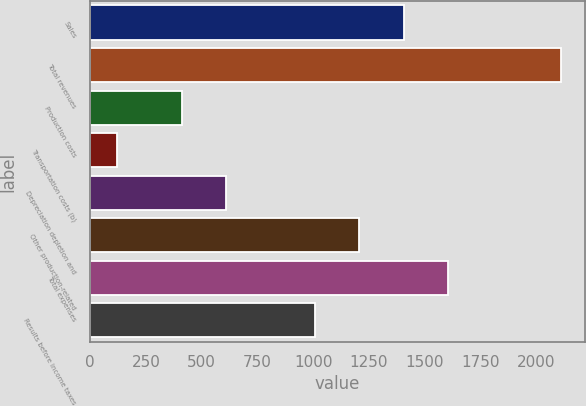<chart> <loc_0><loc_0><loc_500><loc_500><bar_chart><fcel>Sales<fcel>Total revenues<fcel>Production costs<fcel>Transportation costs (b)<fcel>Depreciation depletion and<fcel>Other production-related<fcel>Total expenses<fcel>Results before income taxes<nl><fcel>1406.5<fcel>2113<fcel>410<fcel>120<fcel>609.3<fcel>1207.2<fcel>1605.8<fcel>1007.9<nl></chart> 